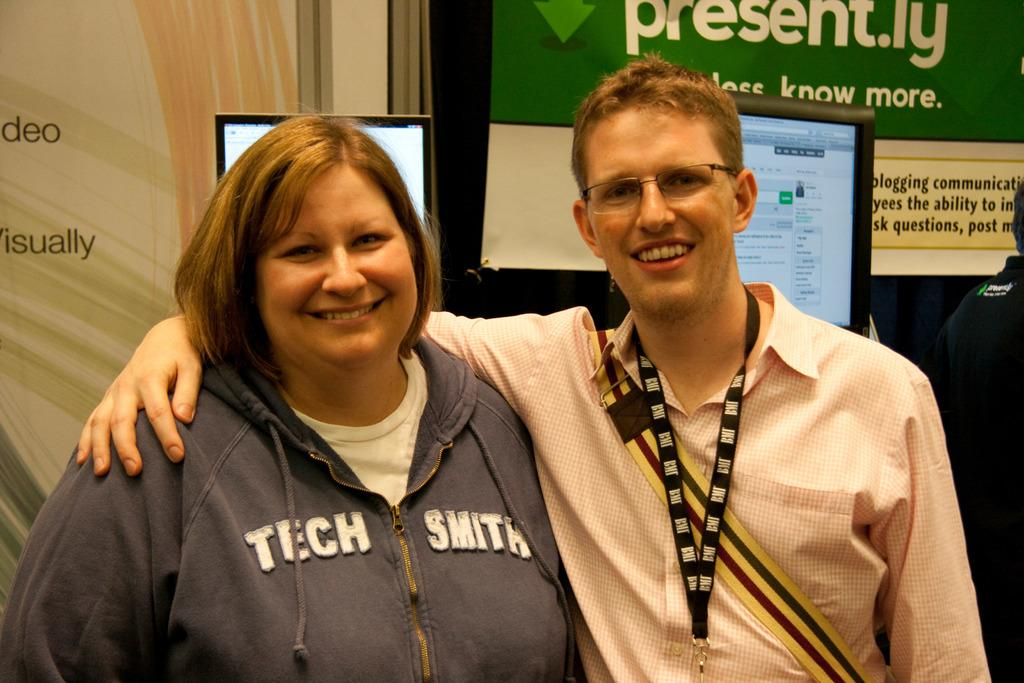How many people are present in the image? There are 2 people in the image. Can you describe any specific features of one of the people? One person is wearing spectacles. What is the other person wearing that can be identified in the image? The other person is wearing an id card. What can be seen in the background of the image? There are screens visible in the background. How many goats are present in the image? There are no goats present in the image. Can you describe the behavior of the ants in the image? There are no ants present in the image. 